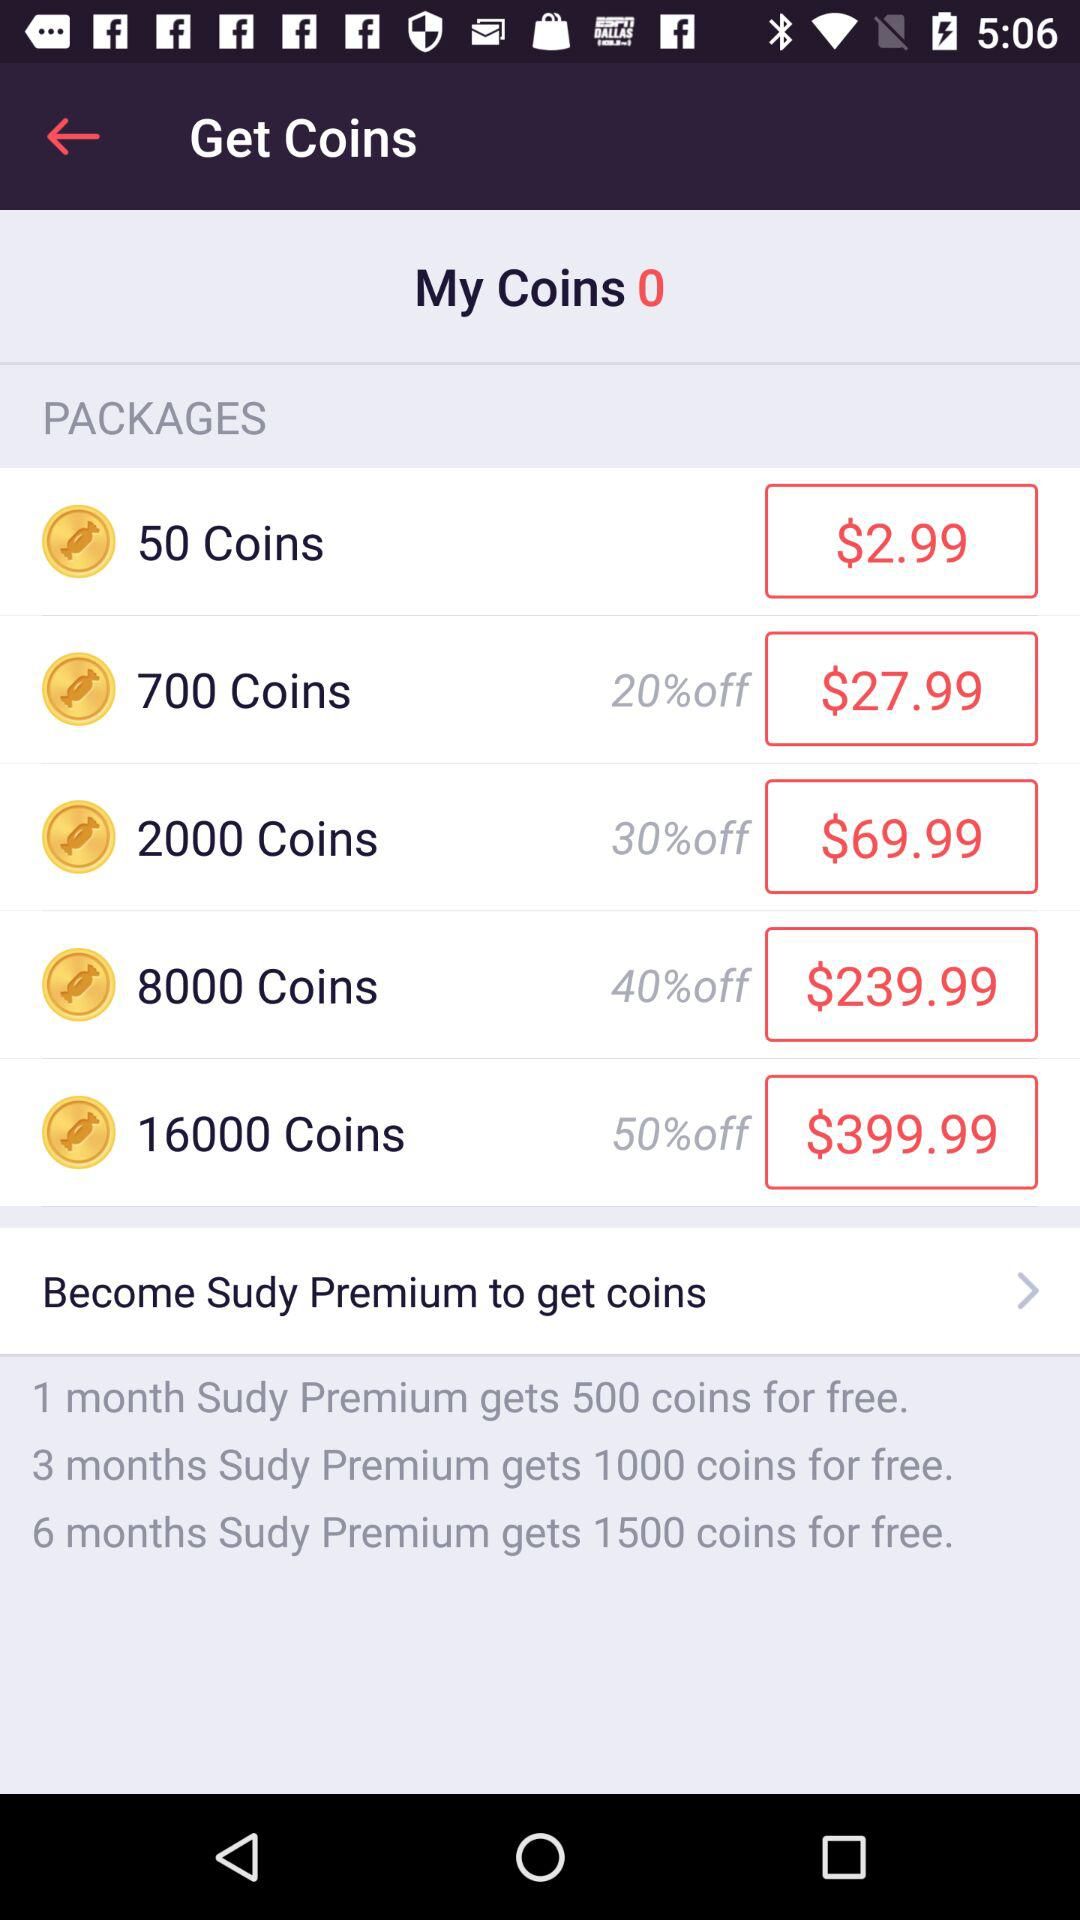What is the price of 50 coins? The price of 50 coins is $2.99. 